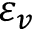Convert formula to latex. <formula><loc_0><loc_0><loc_500><loc_500>\varepsilon _ { v }</formula> 